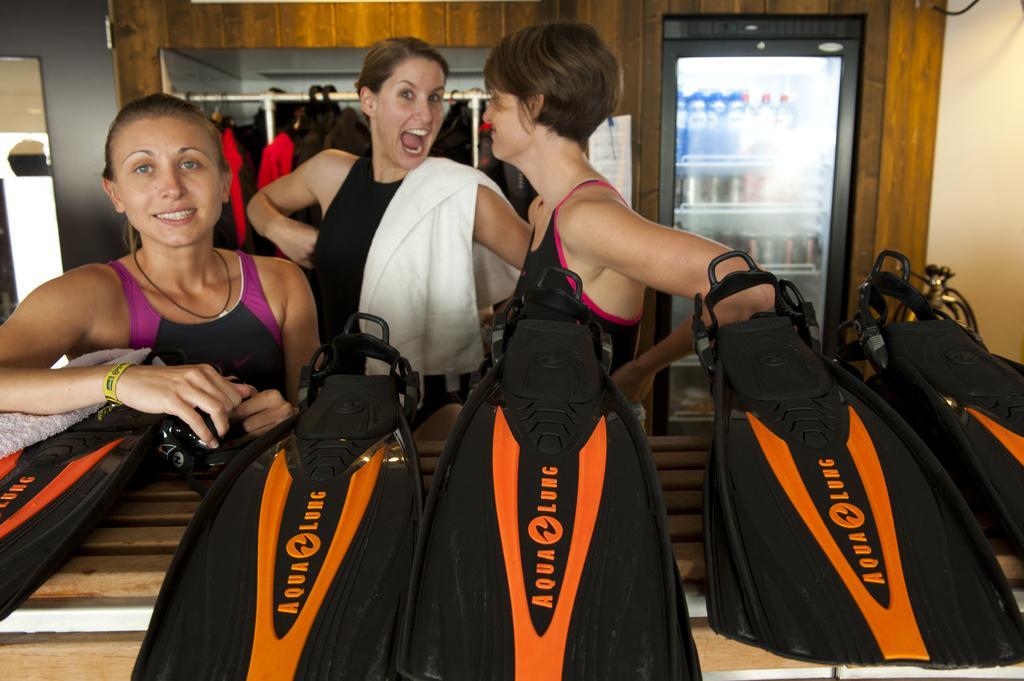In one or two sentences, can you explain what this image depicts? As we can see in the image there are black color bags, clothes and hangers. There is a wall and vending machine. In vending machine there are bottles. 